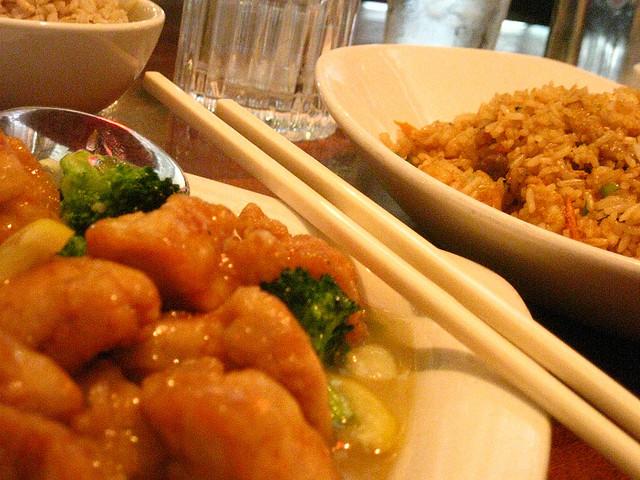What utensils are shown here?
Write a very short answer. Chopsticks. Is this Italian?
Give a very brief answer. No. What kind of food is this?
Concise answer only. Chinese. 